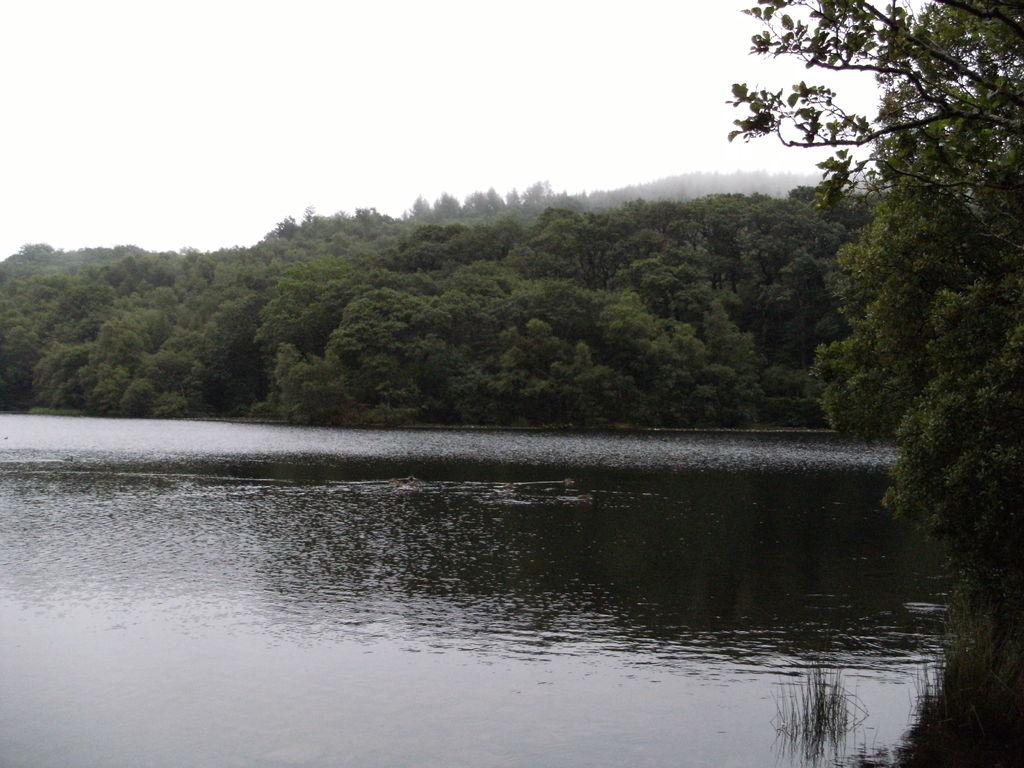What is located in the middle of the image? There is water in the middle of the image. What can be seen in the background of the image? There is a forest in the background of the image. What is visible at the top of the image? The sky is visible at the top of the image. What type of coil can be seen in the image? There is no coil present in the image. What season is depicted in the image? The provided facts do not mention any season, so it cannot be determined from the image. 